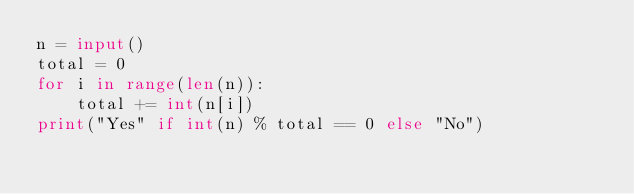Convert code to text. <code><loc_0><loc_0><loc_500><loc_500><_Python_>n = input()
total = 0
for i in range(len(n)):
    total += int(n[i])
print("Yes" if int(n) % total == 0 else "No")
</code> 